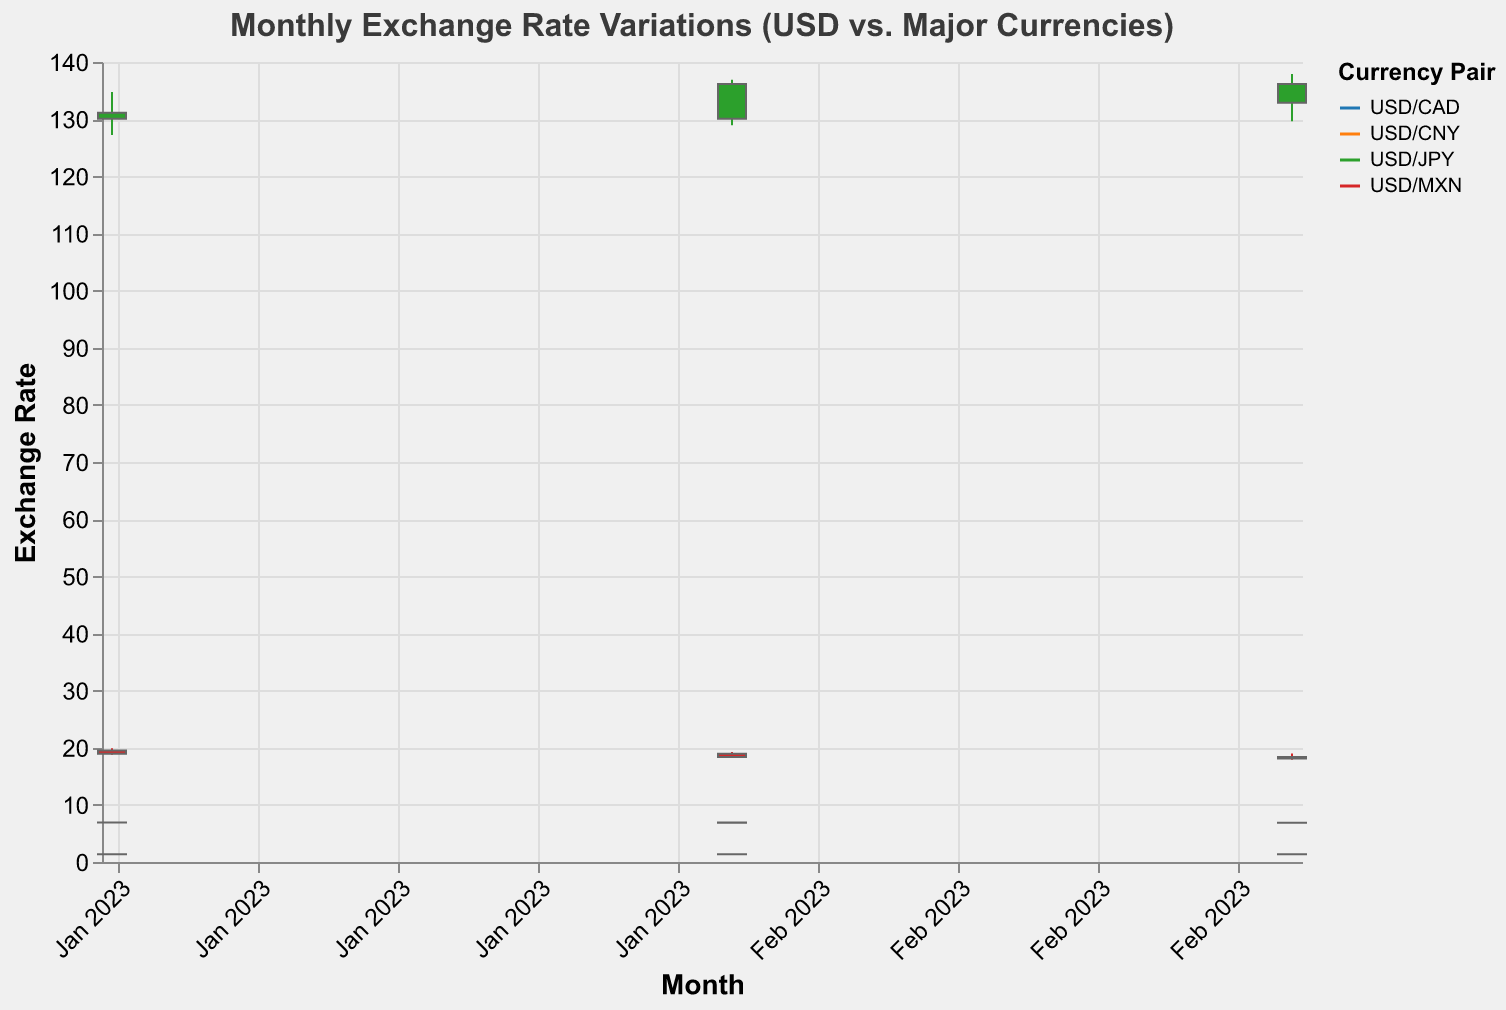Which currency pair shows the highest exchange rate in any month? Look for the maximum value in the "Close" column across all the currency pairs and months. USD/JPY in February shows the highest closing rate of 136.17.
Answer: USD/JPY During which month did USD/CNY have the lowest closing exchange rate? Identify the lowest closing rate for USD/CNY in the "Close" column and note the corresponding month. The lowest closing rate for USD/CNY is 6.8698 in February.
Answer: February For USD/CAD, did the closing exchange rate in March 2023 increase or decrease compared to February 2023? Compare the closing rate for USD/CAD in March (1.3515) with the closing rate in February (1.3595) to see if it increased or decreased. The closing rate decreased.
Answer: Decrease Which currency pair had the widest range of exchange rates (difference between High and Low) in January 2023? Calculate the range (High - Low) for each currency pair in January 2023 and find the maximum. The ranges are: USD/CNY (6.9225 - 6.8650 = 0.0575), USD/CAD (1.3685 - 1.3315 = 0.0370), USD/MXN (19.8850 - 18.7650 = 1.1200), and USD/JPY (134.77 - 127.22 = 7.55). USD/JPY has the widest range of 7.55.
Answer: USD/JPY How did the exchange rate for USD/CNY change from January to February 2023? Compare the closing rate for USD/CNY in January (6.8986) with February (6.8698). Subtract February's rate from January's rate to find the change. The rate decreased by 0.0288 (6.8986 - 6.8698).
Answer: Decreased by 0.0288 What is the overall trend of the USD/MXN exchange rate from January to March 2023? Observe the closing rates for USD/MXN over the three months: 18.9250 (January), 18.3850 (February), and 18.1150 (March). The trend shows a continuous decrease.
Answer: Decreasing Which month showed the highest volatility for USD/JPY? Calculate the range (High - Low) for USD/JPY in each month: January (134.77 - 127.22 = 7.55), February (136.91 - 128.91 = 8.00), March (137.91 - 129.65 = 8.26). The highest range is in March with a volatility of 8.26.
Answer: March For USD/MXN in February 2023, was the closing rate higher or lower than the opening rate? Compare the closing rate (18.3850) with the opening rate (18.9250) for USD/MXN in February 2023. The closing rate is lower.
Answer: Lower In which month did USD/CNY experience the smallest difference between its high and low exchange rates? Calculate the difference (High - Low) for each month for USD/CNY: January (0.0575), February (0.1250), March (0.0925). The smallest difference is in January (0.0575).
Answer: January 